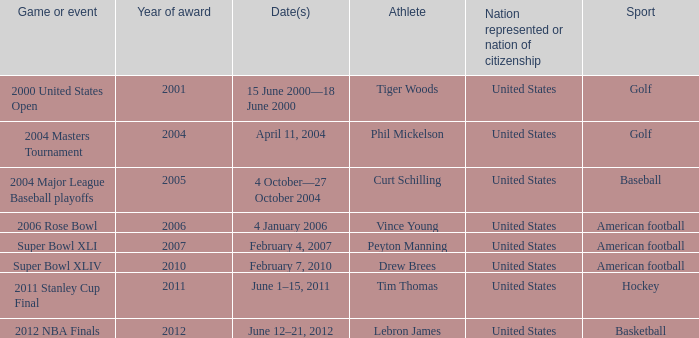In 2011 which sport had the year award? Hockey. 